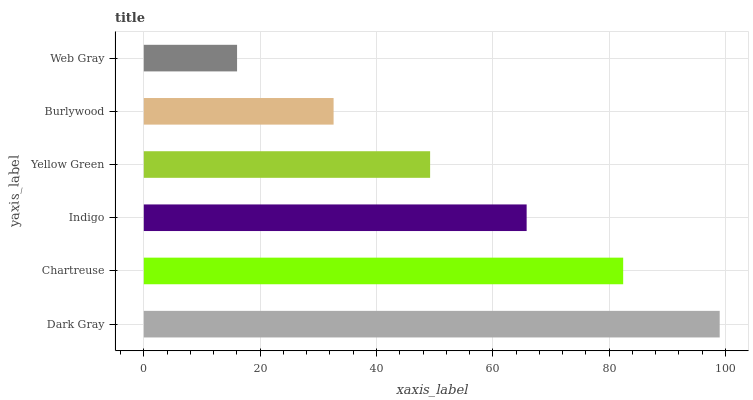Is Web Gray the minimum?
Answer yes or no. Yes. Is Dark Gray the maximum?
Answer yes or no. Yes. Is Chartreuse the minimum?
Answer yes or no. No. Is Chartreuse the maximum?
Answer yes or no. No. Is Dark Gray greater than Chartreuse?
Answer yes or no. Yes. Is Chartreuse less than Dark Gray?
Answer yes or no. Yes. Is Chartreuse greater than Dark Gray?
Answer yes or no. No. Is Dark Gray less than Chartreuse?
Answer yes or no. No. Is Indigo the high median?
Answer yes or no. Yes. Is Yellow Green the low median?
Answer yes or no. Yes. Is Web Gray the high median?
Answer yes or no. No. Is Chartreuse the low median?
Answer yes or no. No. 